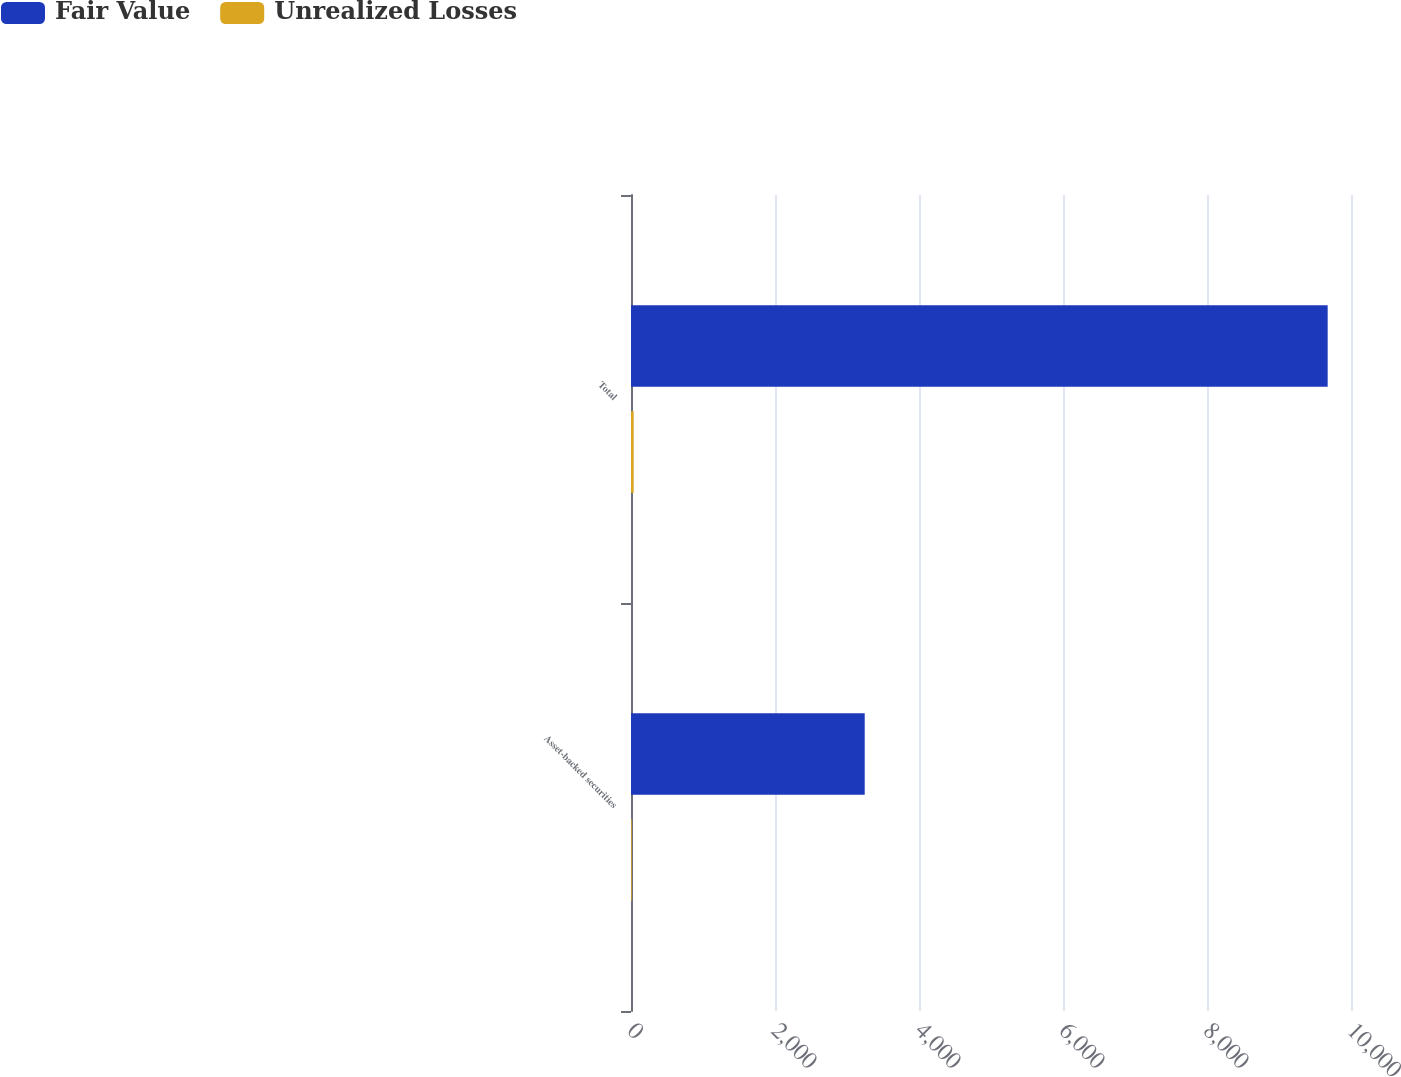Convert chart. <chart><loc_0><loc_0><loc_500><loc_500><stacked_bar_chart><ecel><fcel>Asset-backed securities<fcel>Total<nl><fcel>Fair Value<fcel>3246<fcel>9676<nl><fcel>Unrealized Losses<fcel>10<fcel>37<nl></chart> 